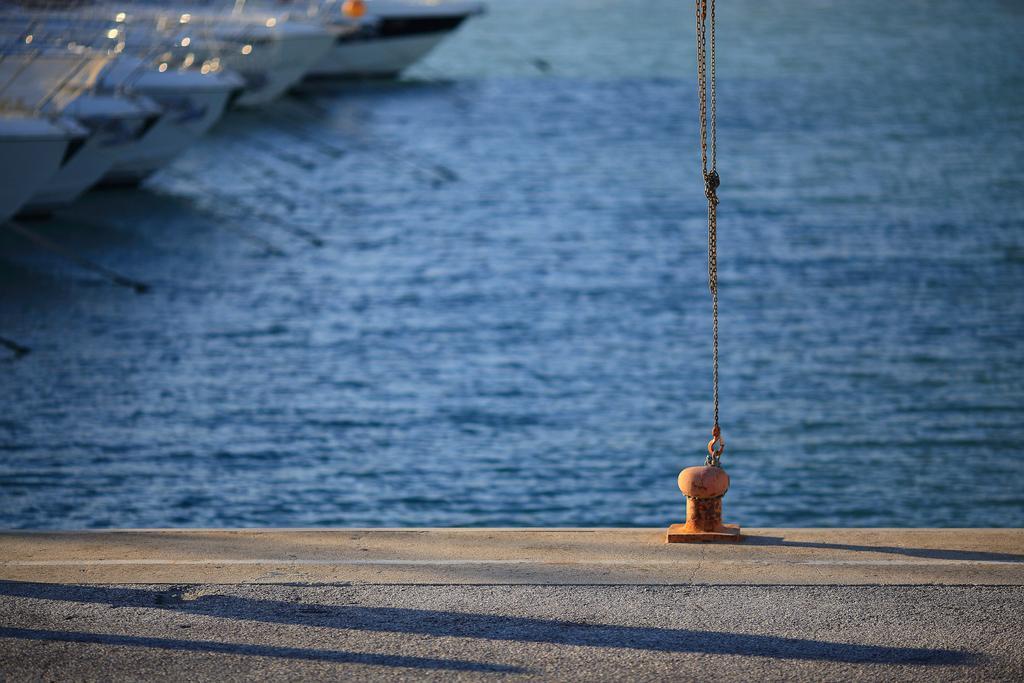Describe this image in one or two sentences. In this picture I can see the lake. In the top left corner I can see many boats. At the bottom I can see the road. On the right I can see the chain which is attached to this rod. 